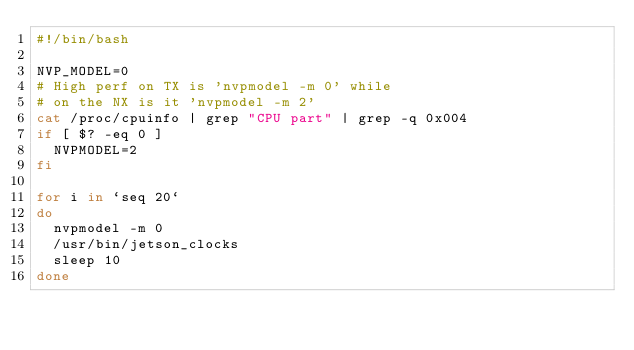<code> <loc_0><loc_0><loc_500><loc_500><_Bash_>#!/bin/bash

NVP_MODEL=0
# High perf on TX is 'nvpmodel -m 0' while
# on the NX is it 'nvpmodel -m 2'
cat /proc/cpuinfo | grep "CPU part" | grep -q 0x004
if [ $? -eq 0 ]
	NVPMODEL=2
fi

for i in `seq 20`
do
	nvpmodel -m 0
	/usr/bin/jetson_clocks
	sleep 10
done

</code> 